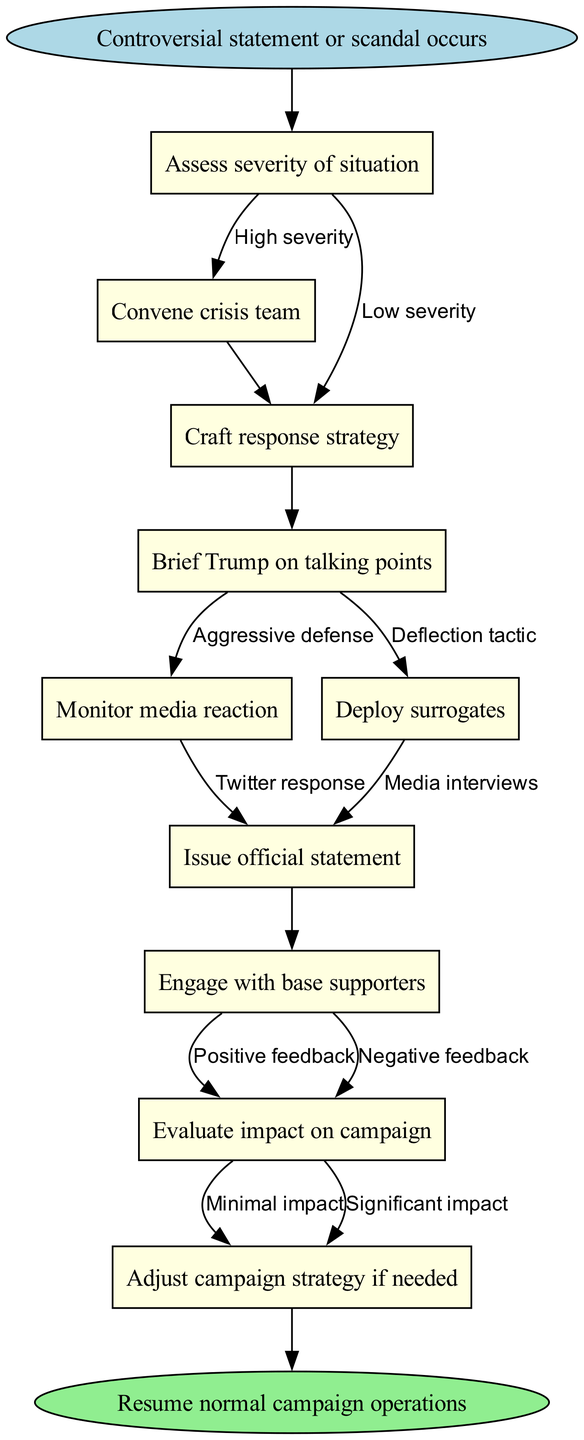What is the first step in the protocol? The diagram indicates that the first step is "Controversial statement or scandal occurs," which is the starting point of the flowchart.
Answer: Controversial statement or scandal occurs How many nodes are in the diagram? There are ten nodes in total, including the start and end nodes, as listed in the provided data.
Answer: 10 What is the last action in the crisis management protocol? The final action listed in the diagram is "Resume normal campaign operations," which is labeled as the end of the flowchart.
Answer: Resume normal campaign operations What happens after assessing the severity of the situation if it is high? If the severity is high, the next step is to convene the crisis team, as shown by the arrow leading from the assessment node to that action.
Answer: Convene crisis team Which strategy is deployed after crafting the response? After crafting a response strategy, the next action indicated in the flowchart is to "Brief Trump on talking points," connecting these two nodes directly.
Answer: Brief Trump on talking points What kind of feedback leads to adjustment in campaign strategy? "Negative feedback" is the type of feedback that, when received, leads to the evaluation of the impact on the campaign and potential adjustments to the strategy.
Answer: Negative feedback What are the two possible outcomes from engaging with base supporters? Engaging with base supporters can result in either "Positive feedback" or "Negative feedback," as indicated by the parallel arrows coming from that node.
Answer: Positive feedback, Negative feedback Which action follows monitoring media reaction? After monitoring media reaction, the diagram shows that "Deploy surrogates" is the next action that occurs in the crisis management flow.
Answer: Deploy surrogates How does the flowchart categorize severity? The diagram categorizes severity as either "High severity" or "Low severity," determining how the protocol will proceed after the assessment step.
Answer: High severity, Low severity 